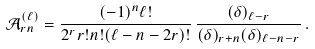Convert formula to latex. <formula><loc_0><loc_0><loc_500><loc_500>\mathcal { A } ^ { ( \ell ) } _ { r n } = \frac { ( - 1 ) ^ { n } \ell ! } { 2 ^ { r } r ! n ! ( \ell - n - 2 r ) ! } \, \frac { ( \delta ) _ { \ell - r } } { ( \delta ) _ { r + n } ( \delta ) _ { \ell - n - r } } \, .</formula> 